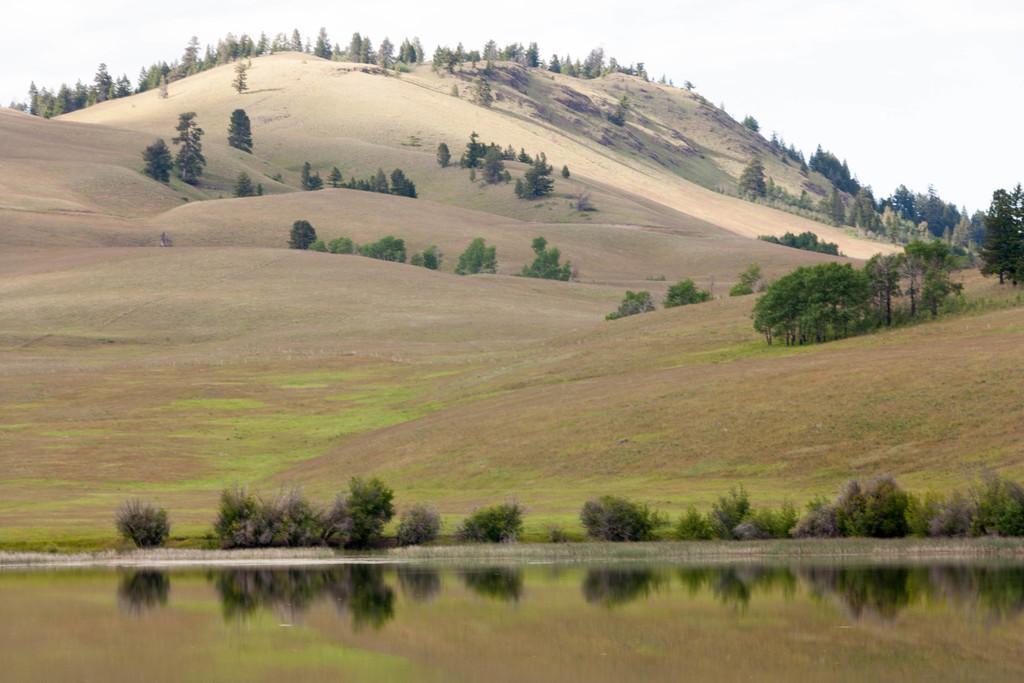Describe this image in one or two sentences. In this image we can see there is a river, trees, mountains and sky. 